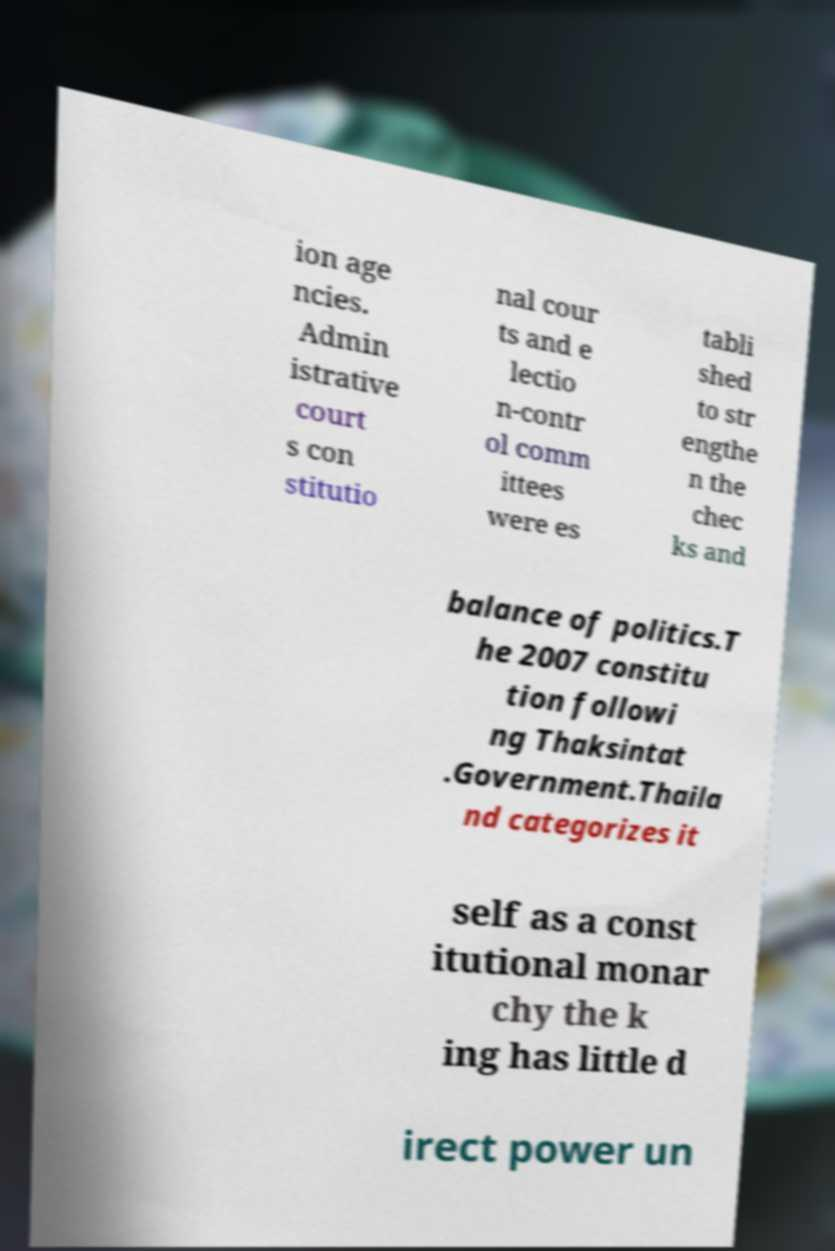Can you read and provide the text displayed in the image?This photo seems to have some interesting text. Can you extract and type it out for me? ion age ncies. Admin istrative court s con stitutio nal cour ts and e lectio n-contr ol comm ittees were es tabli shed to str engthe n the chec ks and balance of politics.T he 2007 constitu tion followi ng Thaksintat .Government.Thaila nd categorizes it self as a const itutional monar chy the k ing has little d irect power un 